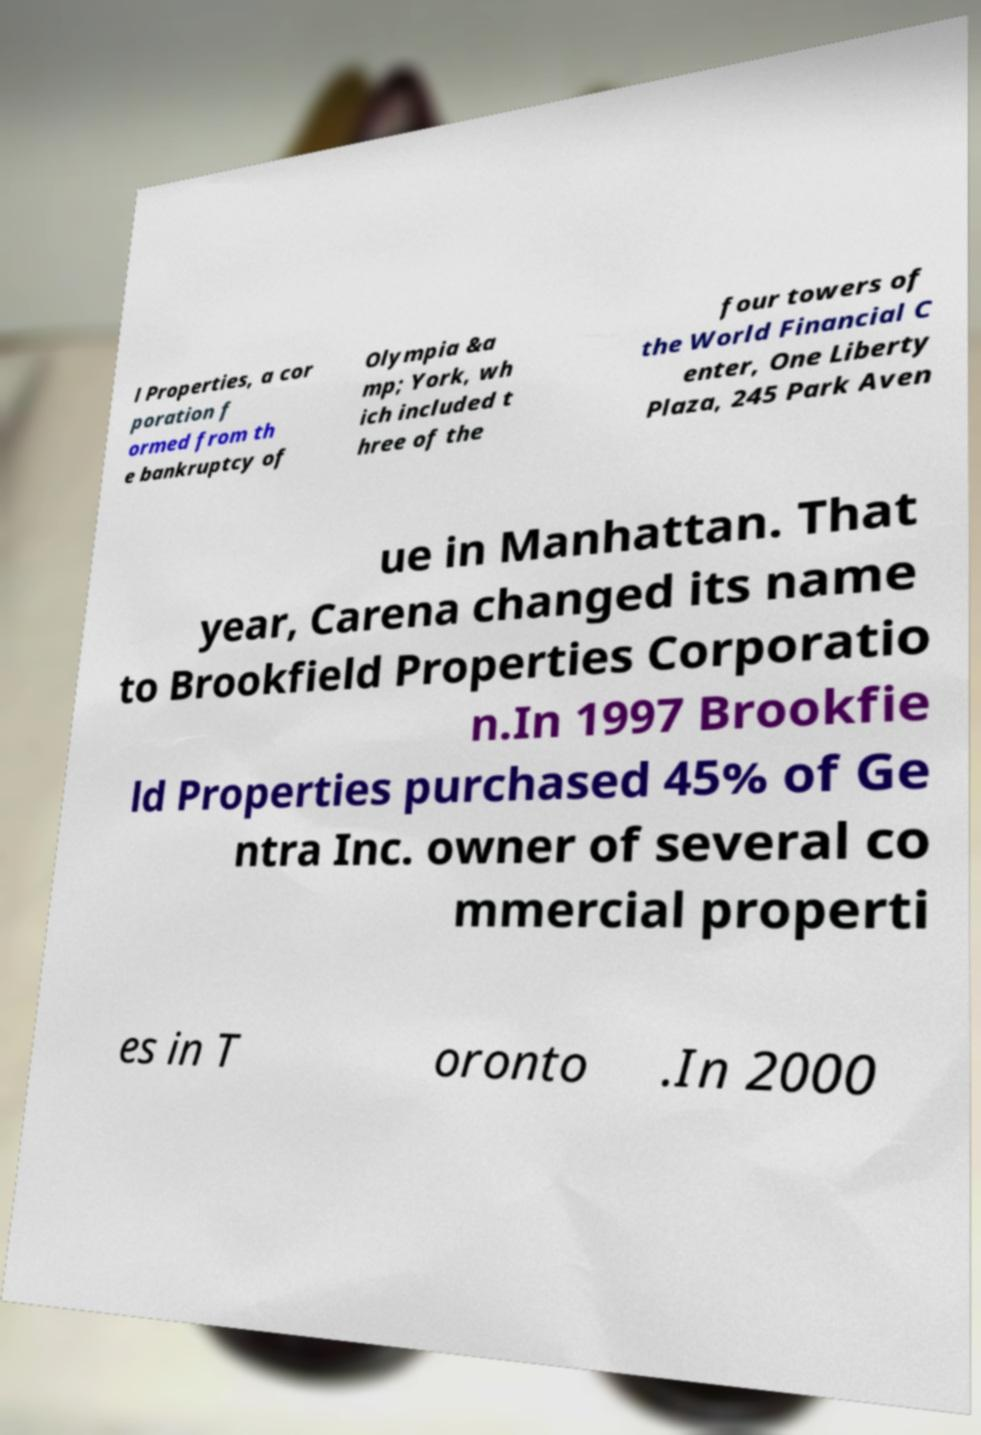Can you accurately transcribe the text from the provided image for me? l Properties, a cor poration f ormed from th e bankruptcy of Olympia &a mp; York, wh ich included t hree of the four towers of the World Financial C enter, One Liberty Plaza, 245 Park Aven ue in Manhattan. That year, Carena changed its name to Brookfield Properties Corporatio n.In 1997 Brookfie ld Properties purchased 45% of Ge ntra Inc. owner of several co mmercial properti es in T oronto .In 2000 